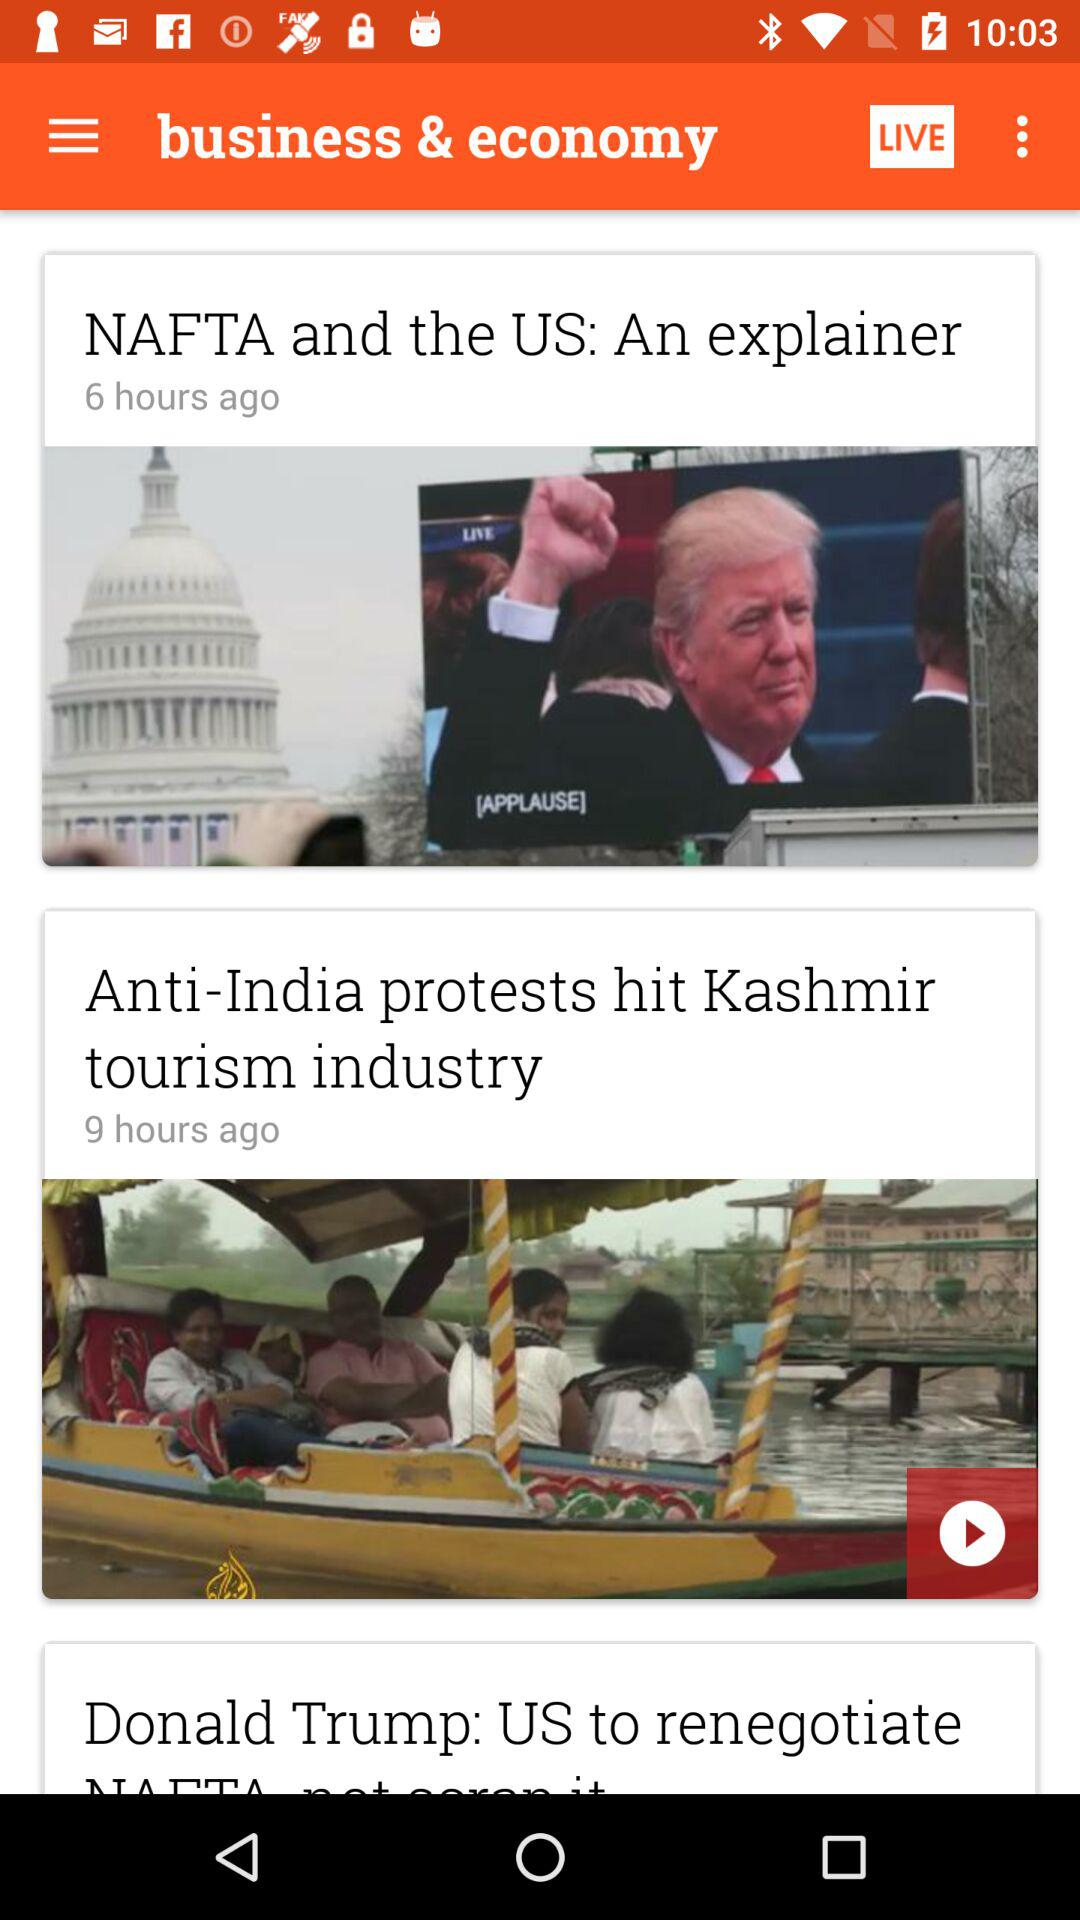Which news has been published in the last 9 hours? The news that has been published in the last 9 hours is "Anti-India protests hit Kashmir tourism industry". 